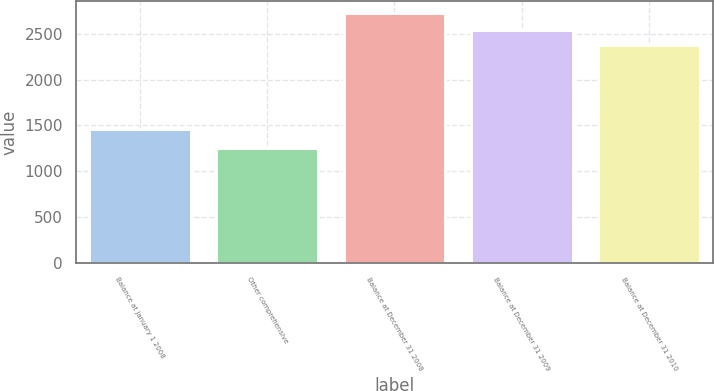<chart> <loc_0><loc_0><loc_500><loc_500><bar_chart><fcel>Balance at January 1 2008<fcel>Other comprehensive<fcel>Balance at December 31 2008<fcel>Balance at December 31 2009<fcel>Balance at December 31 2010<nl><fcel>1461<fcel>1258<fcel>2719<fcel>2541<fcel>2371<nl></chart> 